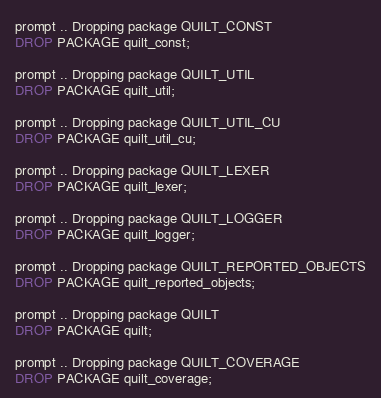Convert code to text. <code><loc_0><loc_0><loc_500><loc_500><_SQL_>prompt .. Dropping package QUILT_CONST
DROP PACKAGE quilt_const;

prompt .. Dropping package QUILT_UTIL
DROP PACKAGE quilt_util;

prompt .. Dropping package QUILT_UTIL_CU
DROP PACKAGE quilt_util_cu;

prompt .. Dropping package QUILT_LEXER
DROP PACKAGE quilt_lexer;

prompt .. Dropping package QUILT_LOGGER
DROP PACKAGE quilt_logger;

prompt .. Dropping package QUILT_REPORTED_OBJECTS
DROP PACKAGE quilt_reported_objects;

prompt .. Dropping package QUILT
DROP PACKAGE quilt;

prompt .. Dropping package QUILT_COVERAGE
DROP PACKAGE quilt_coverage;
</code> 